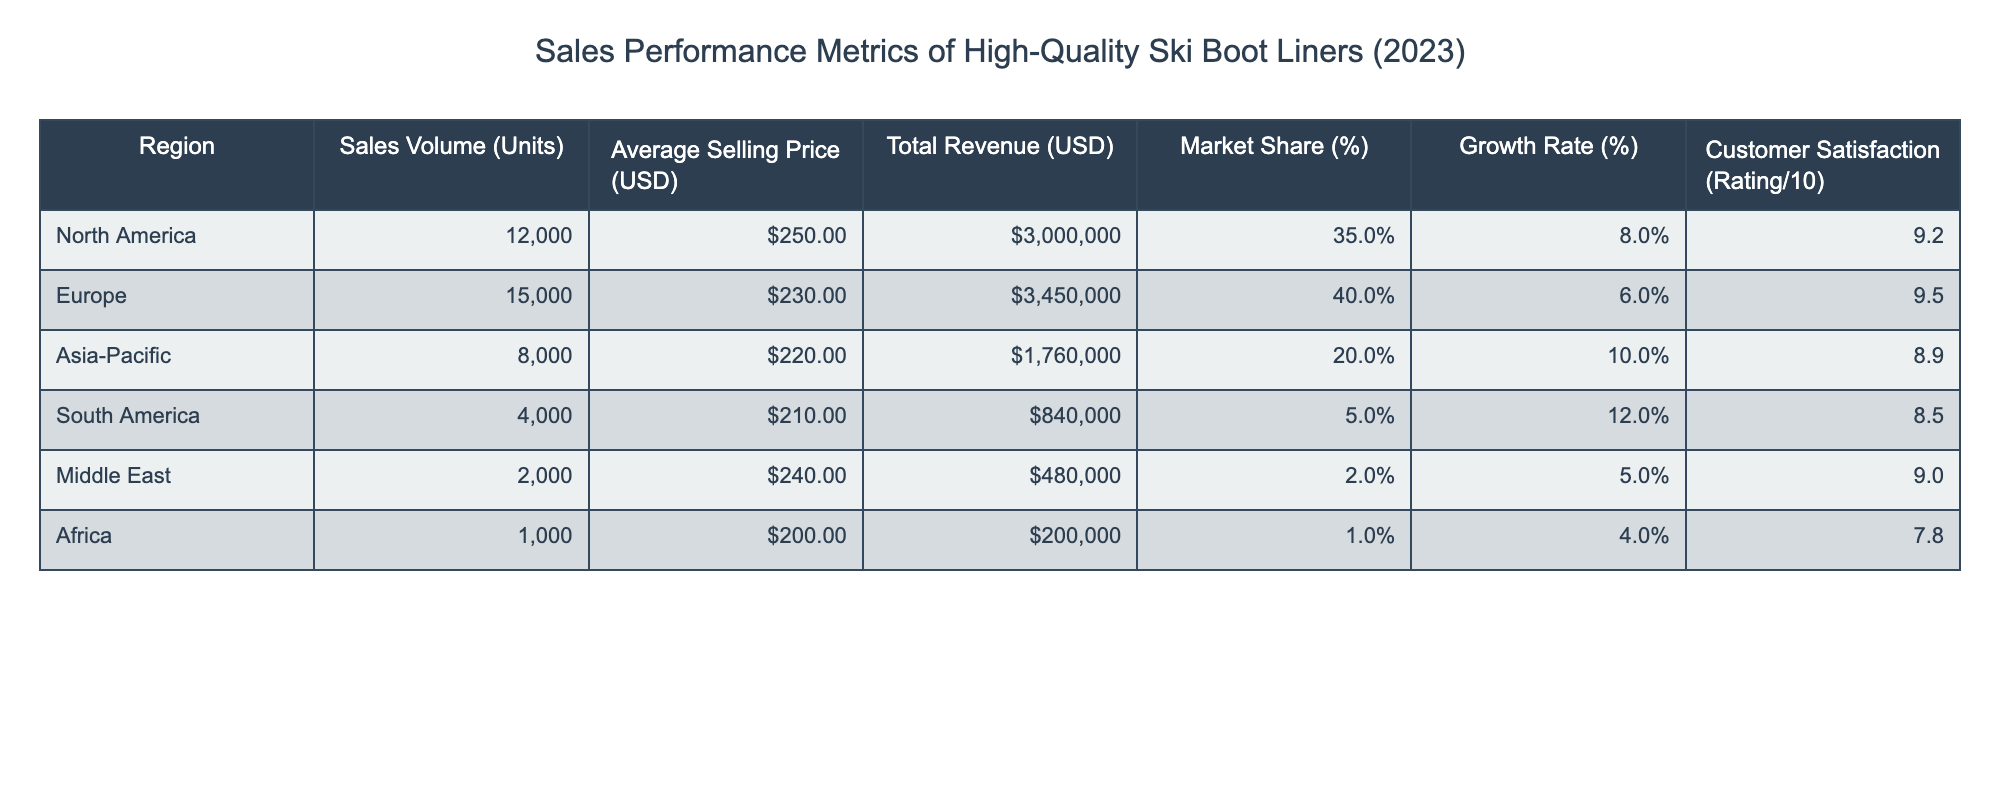What is the total revenue generated in North America? The total revenue for North America is directly listed in the table under the "Total Revenue (USD)" column. For North America, the value is $3,000,000.
Answer: $3,000,000 Which region has the highest market share? The "Market Share (%)" column shows the percentage market share for each region. Europe has the highest market share at 40%.
Answer: Europe What is the average selling price of ski boot liners in the Asia-Pacific region? The average selling price can be found in the "Average Selling Price (USD)" column corresponding to the Asia-Pacific region, which is $220.
Answer: $220 If we compare the total revenue of South America and Africa, which one is higher? The total revenue for South America is $840,000, while for Africa, it is $200,000. Since $840,000 is greater than $200,000, South America has a higher total revenue.
Answer: South America What is the growth rate for the region with the lowest customer satisfaction? The region with the lowest customer satisfaction is Africa, with a rating of 7.8. The corresponding growth rate for Africa is 4%.
Answer: 4% What is the difference in sales volume between Europe and South America? The sales volume for Europe is 15,000 units, and for South America, it is 4,000 units. The difference is calculated as 15,000 - 4,000 = 11,000 units.
Answer: 11,000 units Which region has both the lowest sales volume and market share? A quick look at the "Sales Volume (Units)" column shows Africa has the lowest sales volume at 1,000 units. The "Market Share (%)" column confirms it has the lowest share at 1%. Hence, Africa is the region with both the lowest sales volume and market share.
Answer: Africa Is the customer satisfaction rating in North America higher than that in Asia-Pacific? North America has a customer satisfaction rating of 9.2, while Asia-Pacific has 8.9. Since 9.2 is greater than 8.9, the statement is true.
Answer: Yes What is the average customer satisfaction rating across all regions? The customer satisfaction ratings are: 9.2 (North America), 9.5 (Europe), 8.9 (Asia-Pacific), 8.5 (South America), 9.0 (Middle East), and 7.8 (Africa). The average is calculated by summing these values (9.2 + 9.5 + 8.9 + 8.5 + 9.0 + 7.8 = 52.9) and dividing by the number of regions (6), resulting in an average of 52.9/6 = 8.817.
Answer: 8.82 